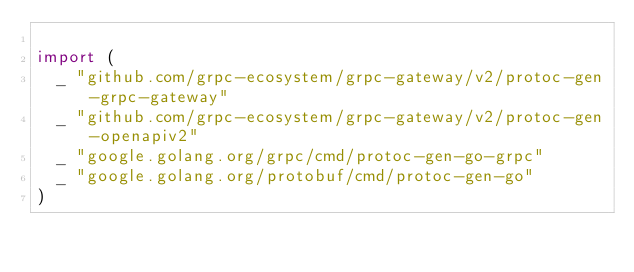Convert code to text. <code><loc_0><loc_0><loc_500><loc_500><_Go_>
import (
	_ "github.com/grpc-ecosystem/grpc-gateway/v2/protoc-gen-grpc-gateway"
	_ "github.com/grpc-ecosystem/grpc-gateway/v2/protoc-gen-openapiv2"
	_ "google.golang.org/grpc/cmd/protoc-gen-go-grpc"
	_ "google.golang.org/protobuf/cmd/protoc-gen-go"
)
</code> 